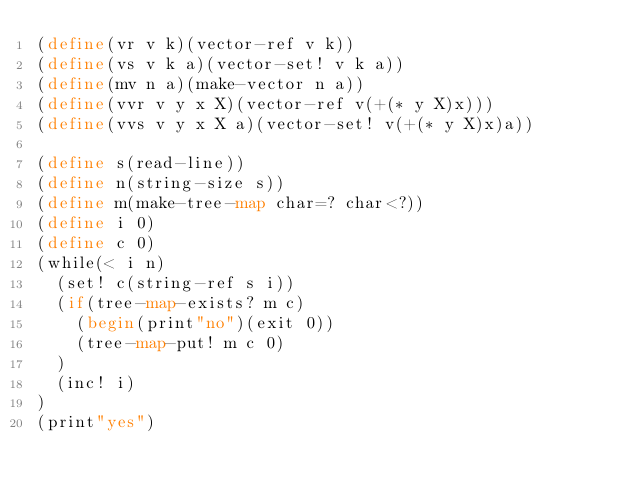<code> <loc_0><loc_0><loc_500><loc_500><_Scheme_>(define(vr v k)(vector-ref v k))
(define(vs v k a)(vector-set! v k a))
(define(mv n a)(make-vector n a))
(define(vvr v y x X)(vector-ref v(+(* y X)x)))
(define(vvs v y x X a)(vector-set! v(+(* y X)x)a))

(define s(read-line))
(define n(string-size s))
(define m(make-tree-map char=? char<?))
(define i 0)
(define c 0)
(while(< i n)
	(set! c(string-ref s i))
	(if(tree-map-exists? m c)
		(begin(print"no")(exit 0))
		(tree-map-put! m c 0)
	)
	(inc! i)
)
(print"yes")</code> 